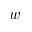<formula> <loc_0><loc_0><loc_500><loc_500>w</formula> 